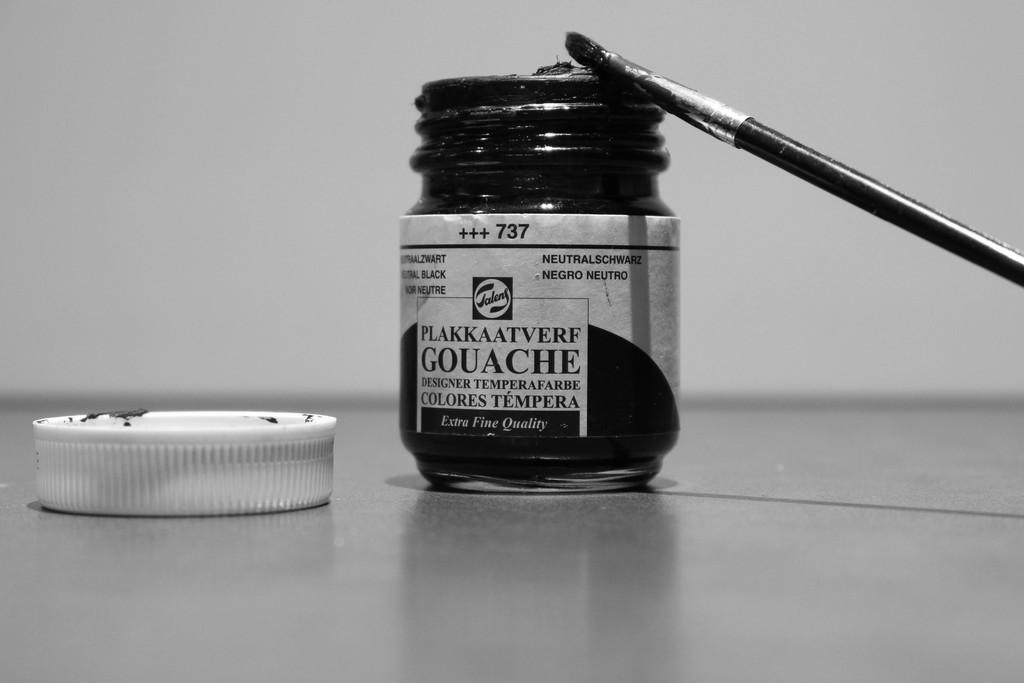What grade of quality is this product?
Make the answer very short. Extra fine. 